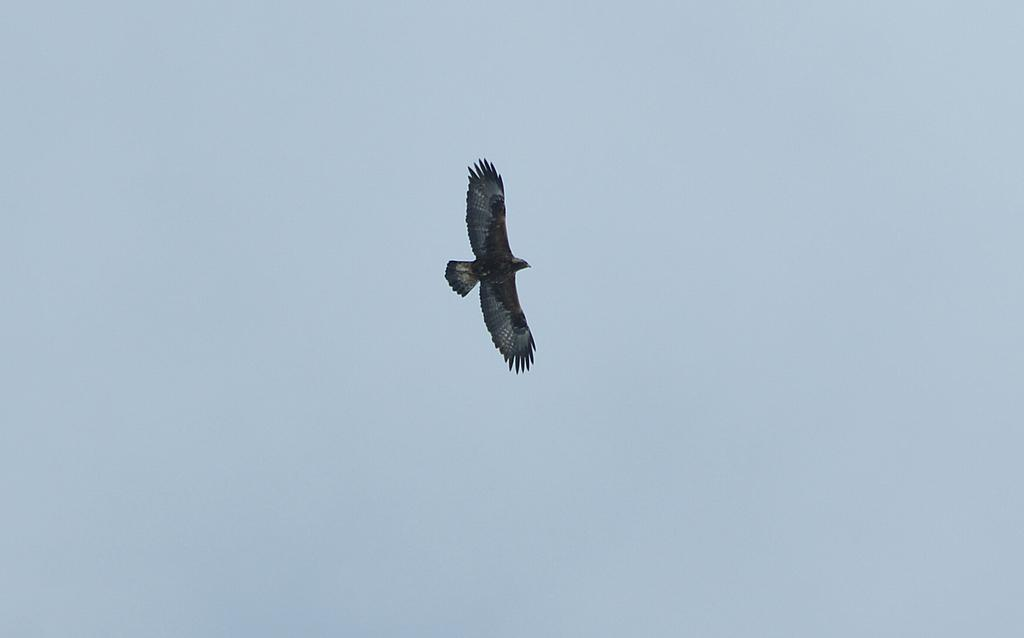What is the main subject of the image? There is a bird flying in the air. What is the color of the sky in the image? The sky is blue. What type of ear is visible on the bird in the image? There is no ear visible on the bird in the image, as birds do not have external ears like mammals. Is there a sink present in the image? There is no sink present in the image; it features a bird flying in the sky. 